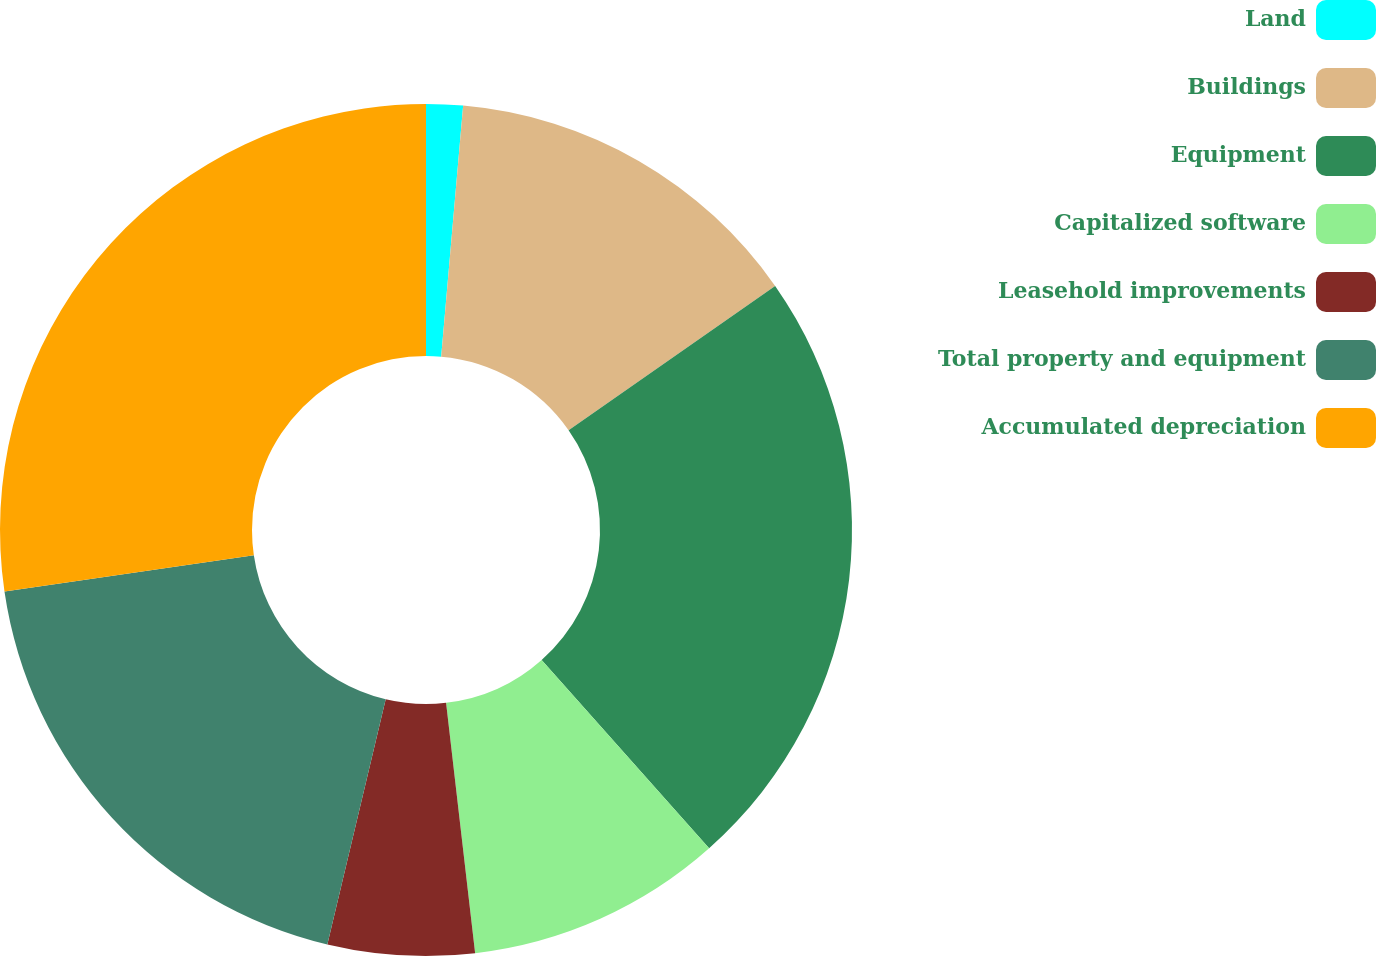Convert chart. <chart><loc_0><loc_0><loc_500><loc_500><pie_chart><fcel>Land<fcel>Buildings<fcel>Equipment<fcel>Capitalized software<fcel>Leasehold improvements<fcel>Total property and equipment<fcel>Accumulated depreciation<nl><fcel>1.39%<fcel>13.9%<fcel>23.14%<fcel>9.73%<fcel>5.56%<fcel>18.97%<fcel>27.31%<nl></chart> 